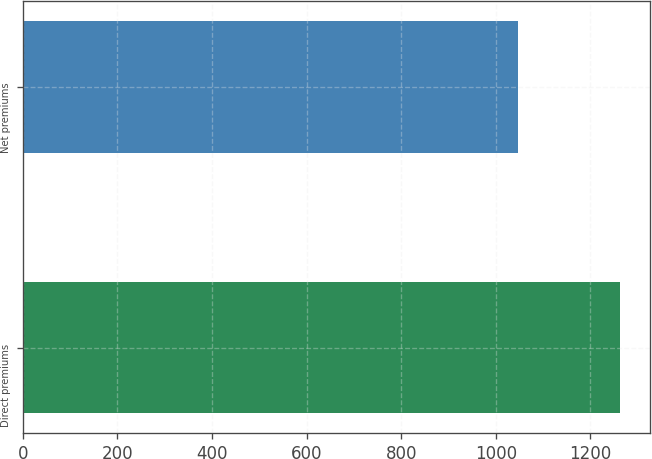<chart> <loc_0><loc_0><loc_500><loc_500><bar_chart><fcel>Direct premiums<fcel>Net premiums<nl><fcel>1263<fcel>1048<nl></chart> 